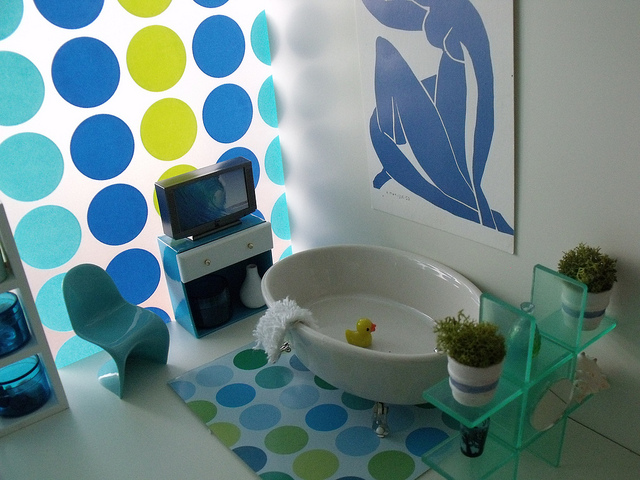<image>What color is in all the pictures? I cannot confirm the particular color in all the pictures. It seems there is blue and white. What color is in all the pictures? I am not sure what color is in all the pictures. However, it can be seen blue in most of the pictures. 